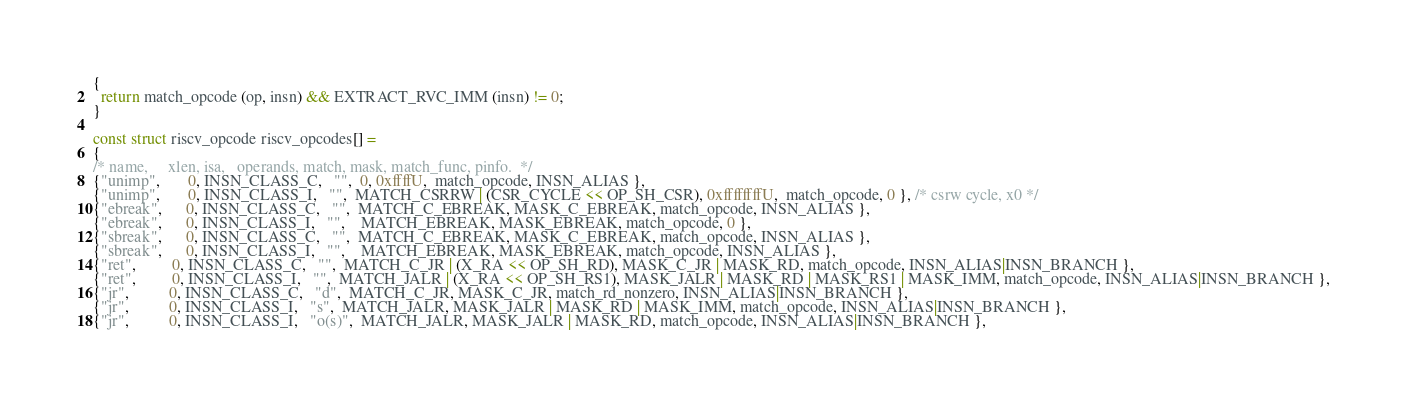<code> <loc_0><loc_0><loc_500><loc_500><_C_>{
  return match_opcode (op, insn) && EXTRACT_RVC_IMM (insn) != 0;
}

const struct riscv_opcode riscv_opcodes[] =
{
/* name,     xlen, isa,   operands, match, mask, match_func, pinfo.  */
{"unimp",       0, INSN_CLASS_C,   "",  0, 0xffffU,  match_opcode, INSN_ALIAS },
{"unimp",       0, INSN_CLASS_I,   "",  MATCH_CSRRW | (CSR_CYCLE << OP_SH_CSR), 0xffffffffU,  match_opcode, 0 }, /* csrw cycle, x0 */
{"ebreak",      0, INSN_CLASS_C,   "",  MATCH_C_EBREAK, MASK_C_EBREAK, match_opcode, INSN_ALIAS },
{"ebreak",      0, INSN_CLASS_I,   "",    MATCH_EBREAK, MASK_EBREAK, match_opcode, 0 },
{"sbreak",      0, INSN_CLASS_C,   "",  MATCH_C_EBREAK, MASK_C_EBREAK, match_opcode, INSN_ALIAS },
{"sbreak",      0, INSN_CLASS_I,   "",    MATCH_EBREAK, MASK_EBREAK, match_opcode, INSN_ALIAS },
{"ret",         0, INSN_CLASS_C,   "",  MATCH_C_JR | (X_RA << OP_SH_RD), MASK_C_JR | MASK_RD, match_opcode, INSN_ALIAS|INSN_BRANCH },
{"ret",         0, INSN_CLASS_I,   "",  MATCH_JALR | (X_RA << OP_SH_RS1), MASK_JALR | MASK_RD | MASK_RS1 | MASK_IMM, match_opcode, INSN_ALIAS|INSN_BRANCH },
{"jr",          0, INSN_CLASS_C,   "d",  MATCH_C_JR, MASK_C_JR, match_rd_nonzero, INSN_ALIAS|INSN_BRANCH },
{"jr",          0, INSN_CLASS_I,   "s",  MATCH_JALR, MASK_JALR | MASK_RD | MASK_IMM, match_opcode, INSN_ALIAS|INSN_BRANCH },
{"jr",          0, INSN_CLASS_I,   "o(s)",  MATCH_JALR, MASK_JALR | MASK_RD, match_opcode, INSN_ALIAS|INSN_BRANCH },</code> 